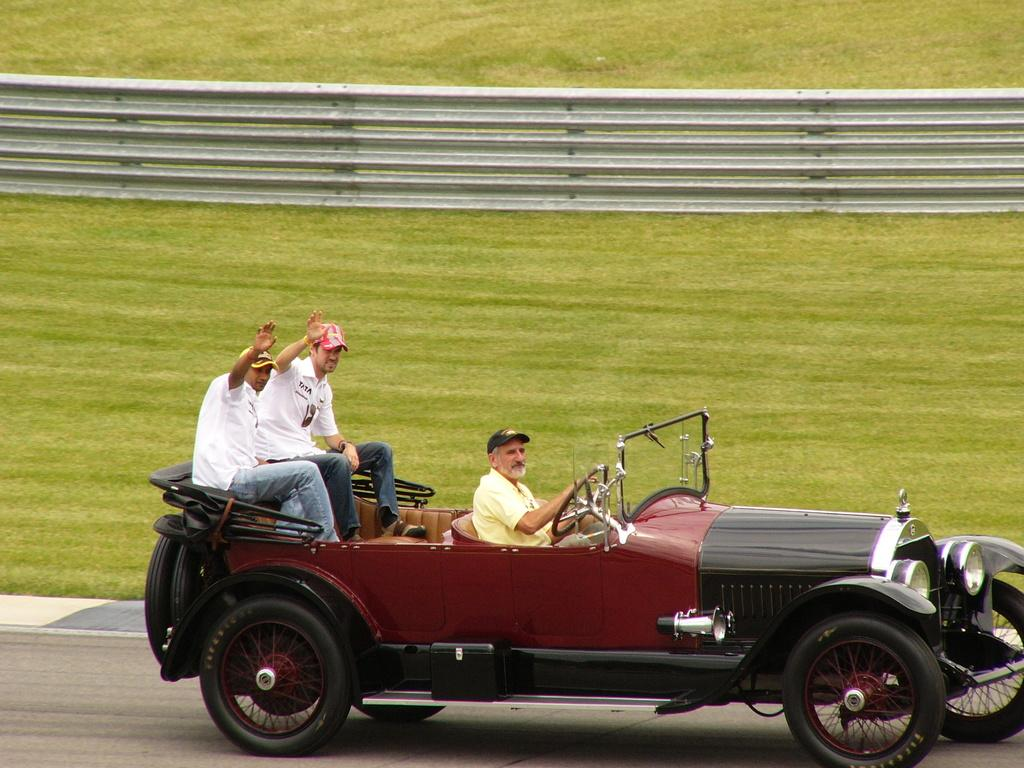What are the people in the image doing? The people in the image are riding in a car. What can be seen in the background of the image? There is a fence and grass in the background of the image. What type of straw is being used to fuel the car in the image? There is no straw present in the image, and the car is not being fueled by straw. 